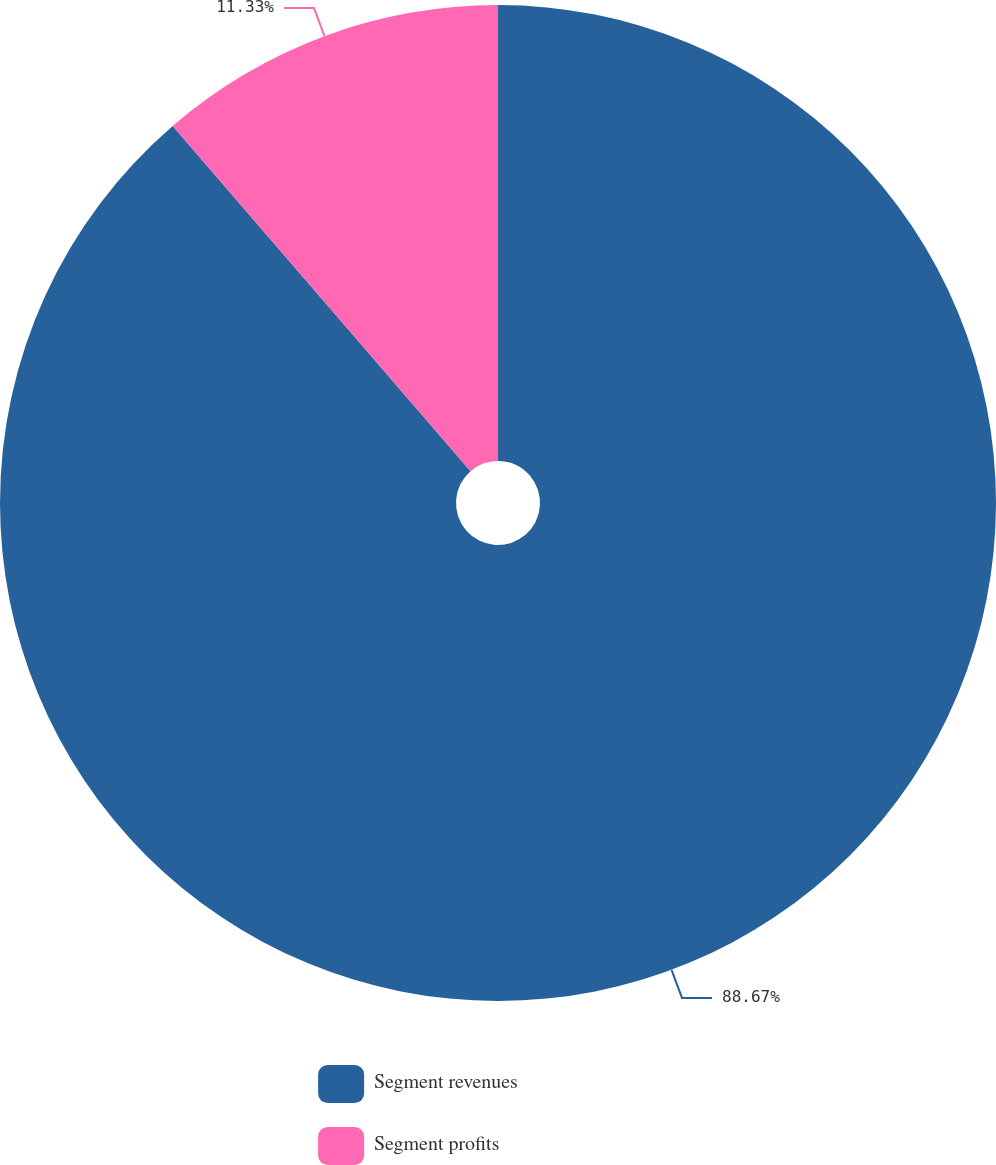Convert chart to OTSL. <chart><loc_0><loc_0><loc_500><loc_500><pie_chart><fcel>Segment revenues<fcel>Segment profits<nl><fcel>88.67%<fcel>11.33%<nl></chart> 